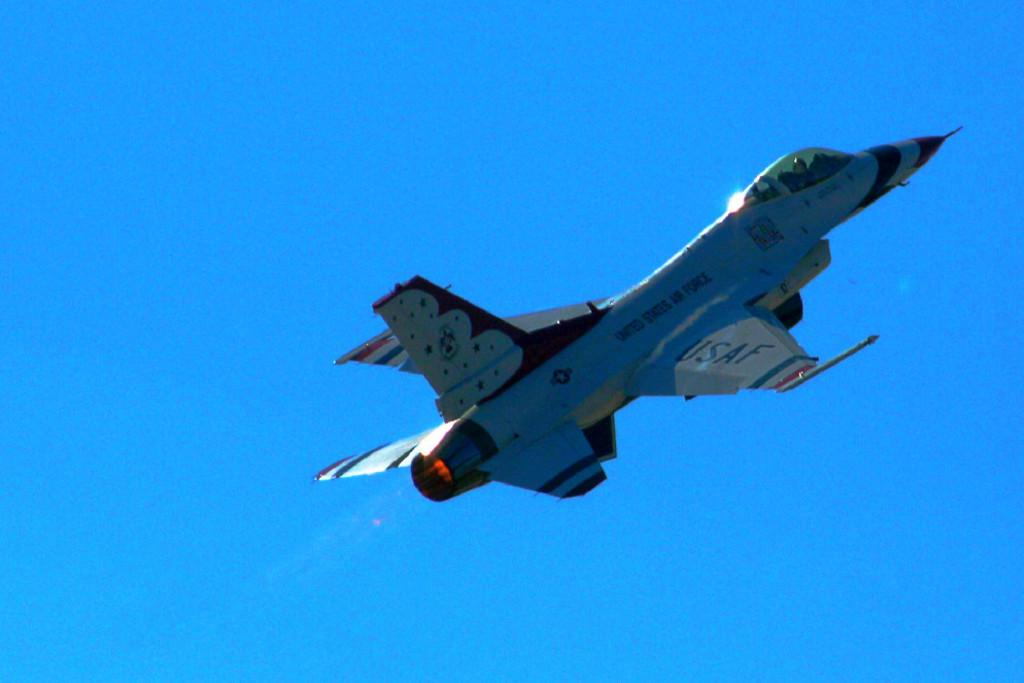<image>
Render a clear and concise summary of the photo. A United States Air Force Jet soars the open blue skys 